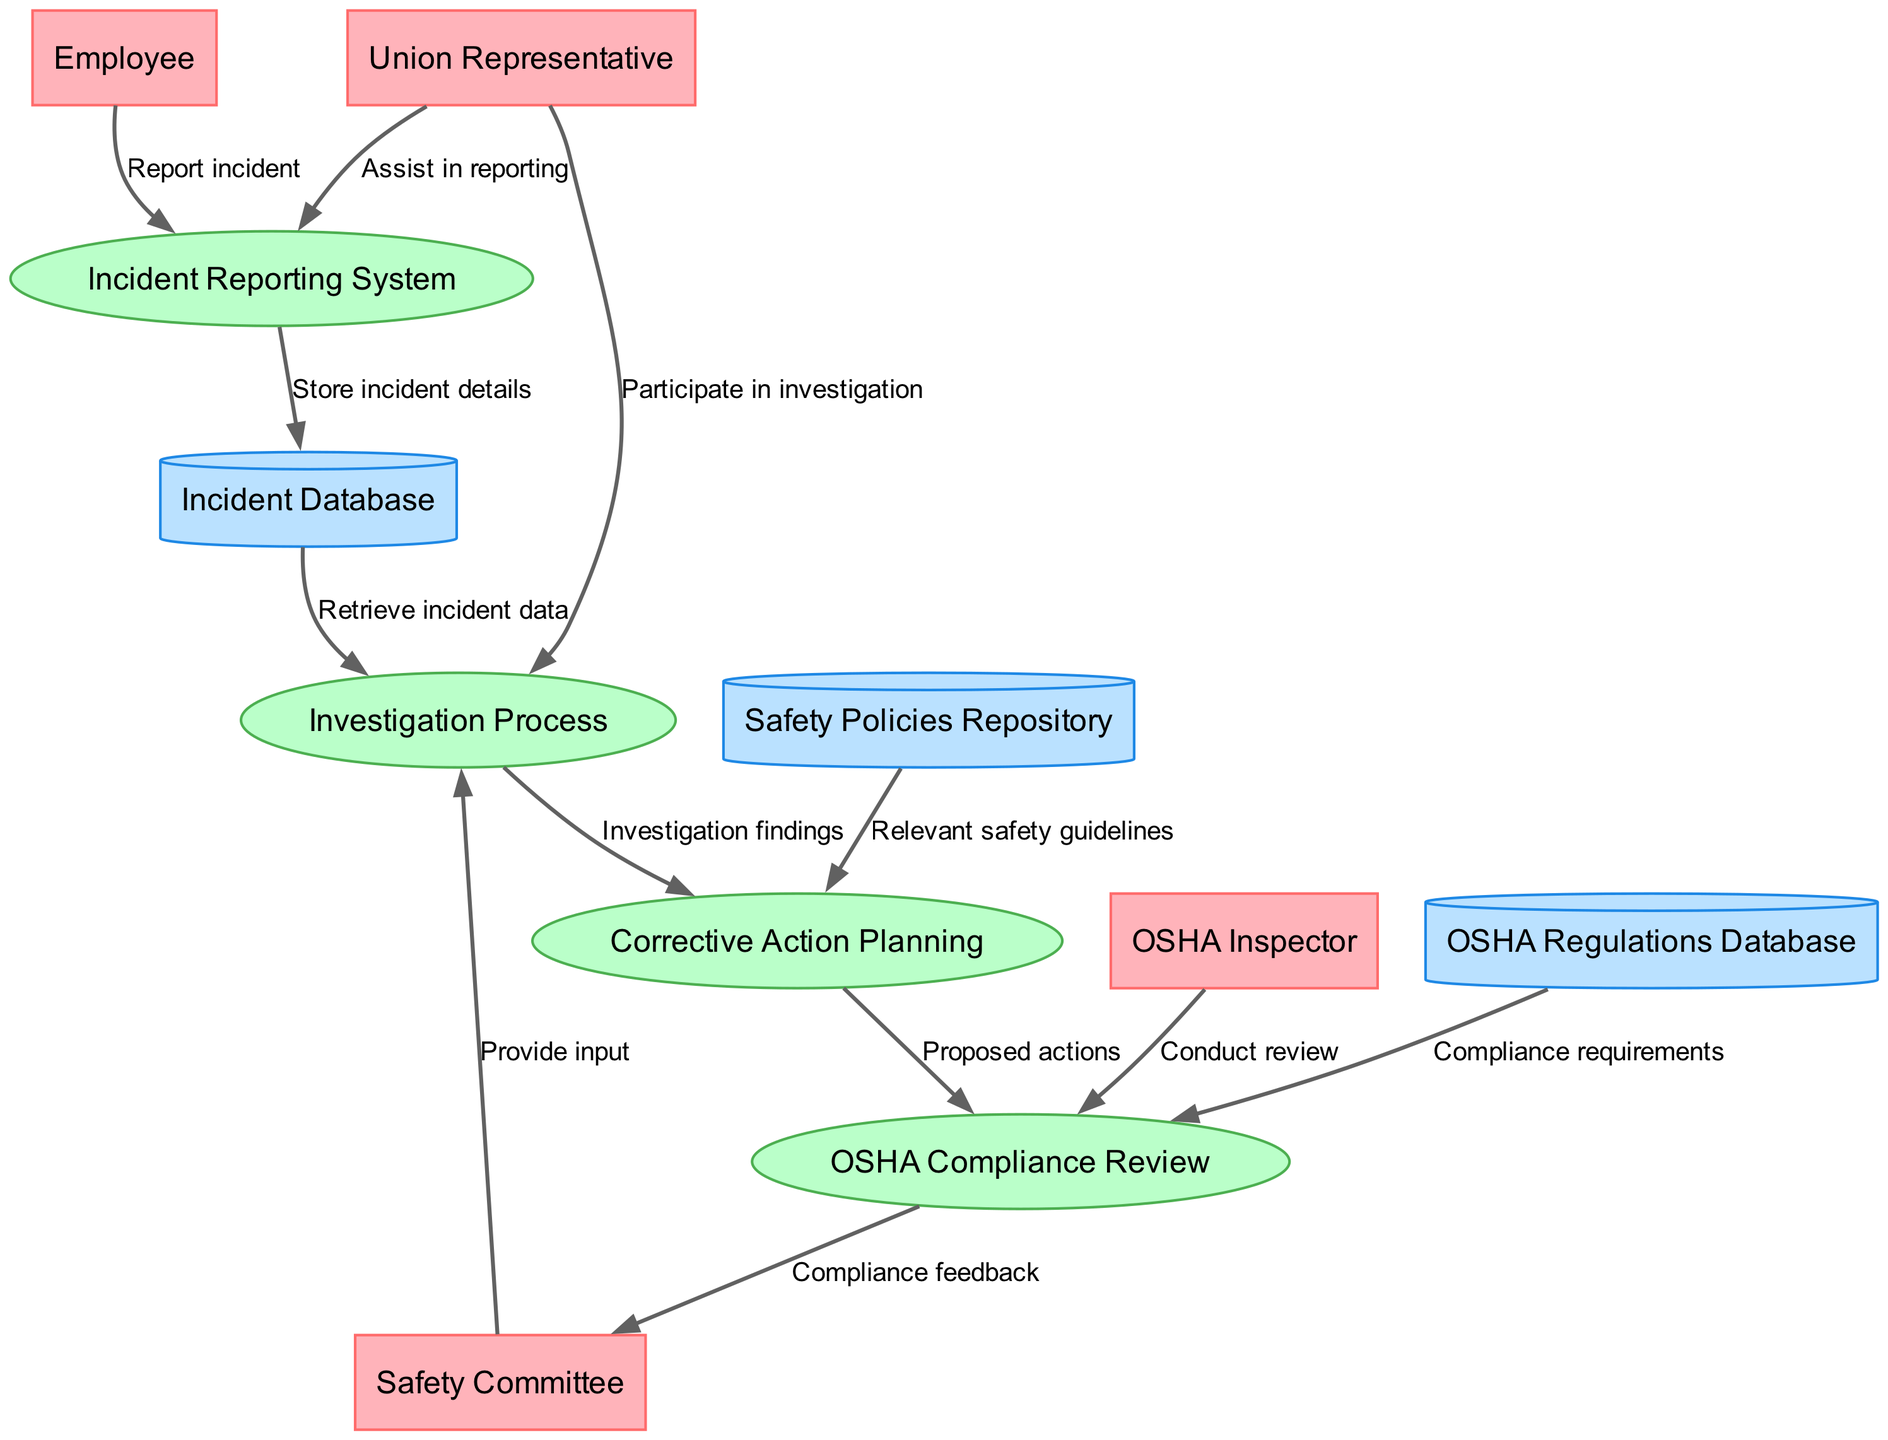What is the first step in the incident reporting process? The first step involves the "Employee" reporting the incident to the "Incident Reporting System". This is indicated by the data flow labeled "Report incident" connecting the "Employee" to the "Incident Reporting System".
Answer: Report incident Who assists in the incident reporting? The "Union Representative" assists in reporting by providing support to the "Incident Reporting System". This is shown through the data flow labeled "Assist in reporting" that connects the "Union Representative" and the "Incident Reporting System".
Answer: Union Representative How many processes are in this diagram? There are four processes in the diagram: "Incident Reporting System", "Investigation Process", "Corrective Action Planning", and "OSHA Compliance Review". This can be counted directly in the processes section of the diagram.
Answer: Four What data store is used to retrieve incident data for investigation? The "Incident Database" is used to retrieve incident data for the investigation process. This is indicated by the flow labeled "Retrieve incident data", which connects the "Incident Database" to the "Investigation Process".
Answer: Incident Database What role does the Safety Committee have during the investigation process? The "Safety Committee" provides input during the investigation process, as shown by the data flow labeled "Provide input" that connects the "Safety Committee" to the "Investigation Process".
Answer: Provide input What is the final output of the investigation process? The final output of the "Investigation Process" is the "Investigation findings", which are sent to the "Corrective Action Planning". This flow indicates that the findings influence the next stage of safety measures.
Answer: Investigation findings What do we review to ensure OSHA compliance? The "OSHA Compliance Review" process requires both "Proposed actions" from "Corrective Action Planning" and "Compliance requirements" from the "OSHA Regulations Database". This indicates that both elements are vital to the review process.
Answer: Proposed actions and Compliance requirements What agency conducts the OSHA compliance review? The "OSHA Inspector" conducts the "OSHA Compliance Review". This is shown by the data flow labeled "Conduct review" connecting the "OSHA Inspector" to the "OSHA Compliance Review".
Answer: OSHA Inspector What does the Compliance Review provide to the Safety Committee? The "OSHA Compliance Review" provides "Compliance feedback" to the "Safety Committee". This is represented by a flow from the "OSHA Compliance Review" back to the "Safety Committee".
Answer: Compliance feedback 